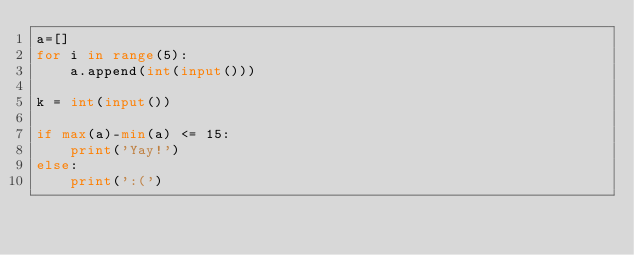Convert code to text. <code><loc_0><loc_0><loc_500><loc_500><_Python_>a=[]
for i in range(5):
	a.append(int(input()))

k = int(input())

if max(a)-min(a) <= 15:
	print('Yay!')
else:
	print(':(')</code> 